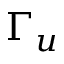Convert formula to latex. <formula><loc_0><loc_0><loc_500><loc_500>\Gamma _ { u }</formula> 